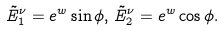<formula> <loc_0><loc_0><loc_500><loc_500>\tilde { E } ^ { \nu } _ { 1 } = e ^ { w } \sin { \phi } , \, \tilde { E } ^ { \nu } _ { 2 } = e ^ { w } \cos { \phi } .</formula> 